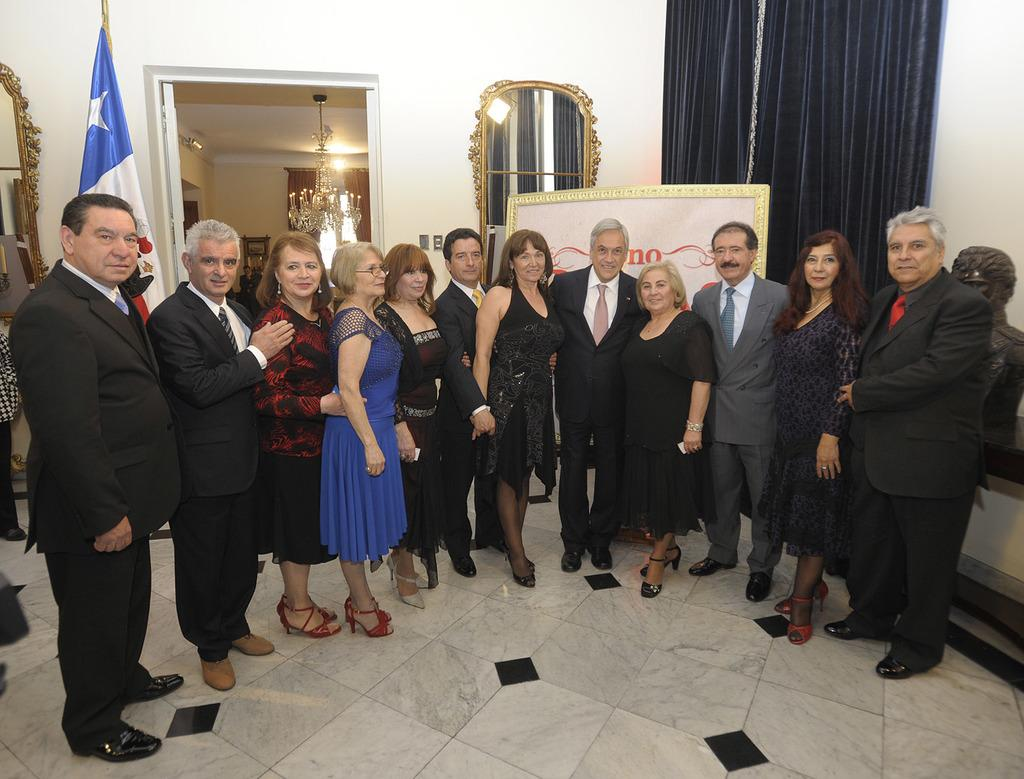How many people are in the image? There is a group of people in the image. What are the people doing in the image? The people are standing on the floor and smiling. What can be seen in the background of the image? There is a flag, a mirror, curtains, a framed object, a chandelier, and a wall in the background of the image. What type of rock is being cooked in the image? There is no rock or cooking activity present in the image. How does the framed object rub against the wall in the image? The framed object does not rub against the wall in the image; it is stationary. 